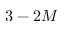<formula> <loc_0><loc_0><loc_500><loc_500>3 - 2 M</formula> 